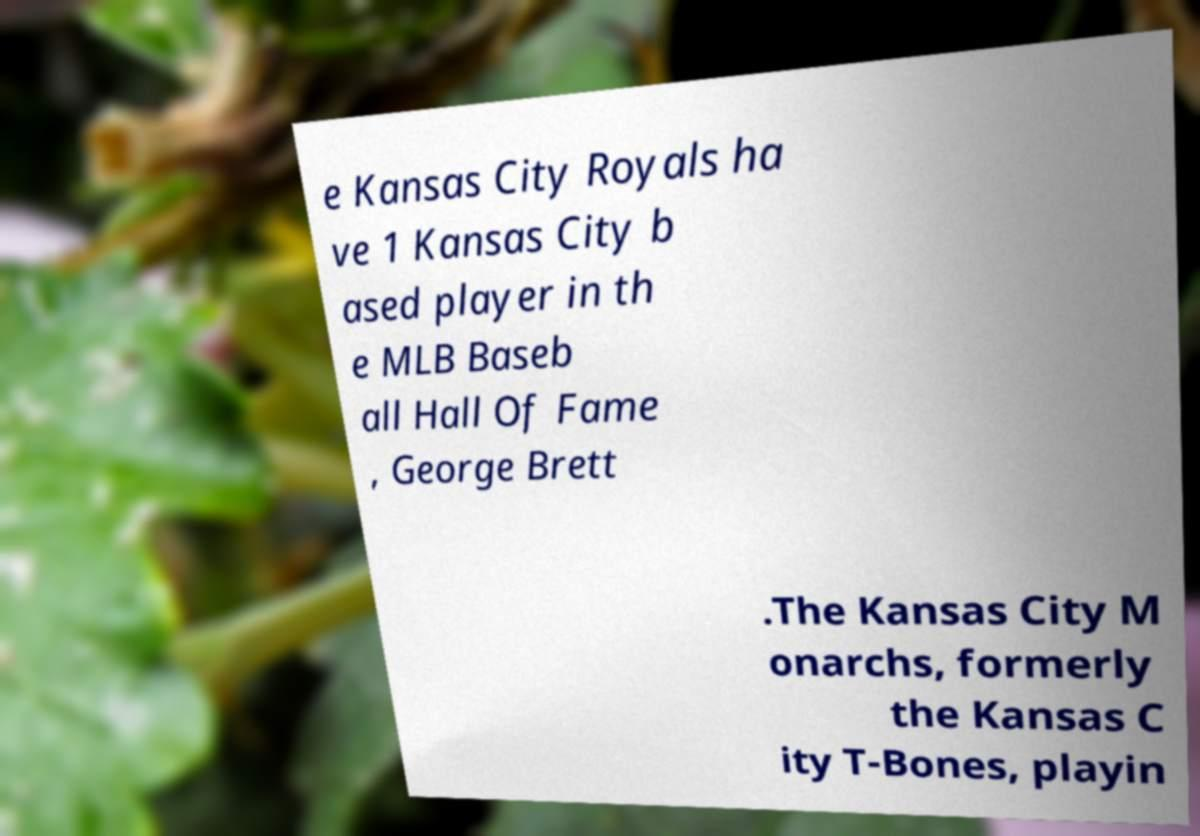What messages or text are displayed in this image? I need them in a readable, typed format. e Kansas City Royals ha ve 1 Kansas City b ased player in th e MLB Baseb all Hall Of Fame , George Brett .The Kansas City M onarchs, formerly the Kansas C ity T-Bones, playin 